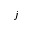Convert formula to latex. <formula><loc_0><loc_0><loc_500><loc_500>j</formula> 